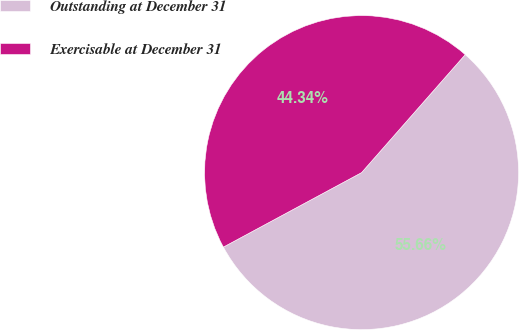Convert chart to OTSL. <chart><loc_0><loc_0><loc_500><loc_500><pie_chart><fcel>Outstanding at December 31<fcel>Exercisable at December 31<nl><fcel>55.66%<fcel>44.34%<nl></chart> 